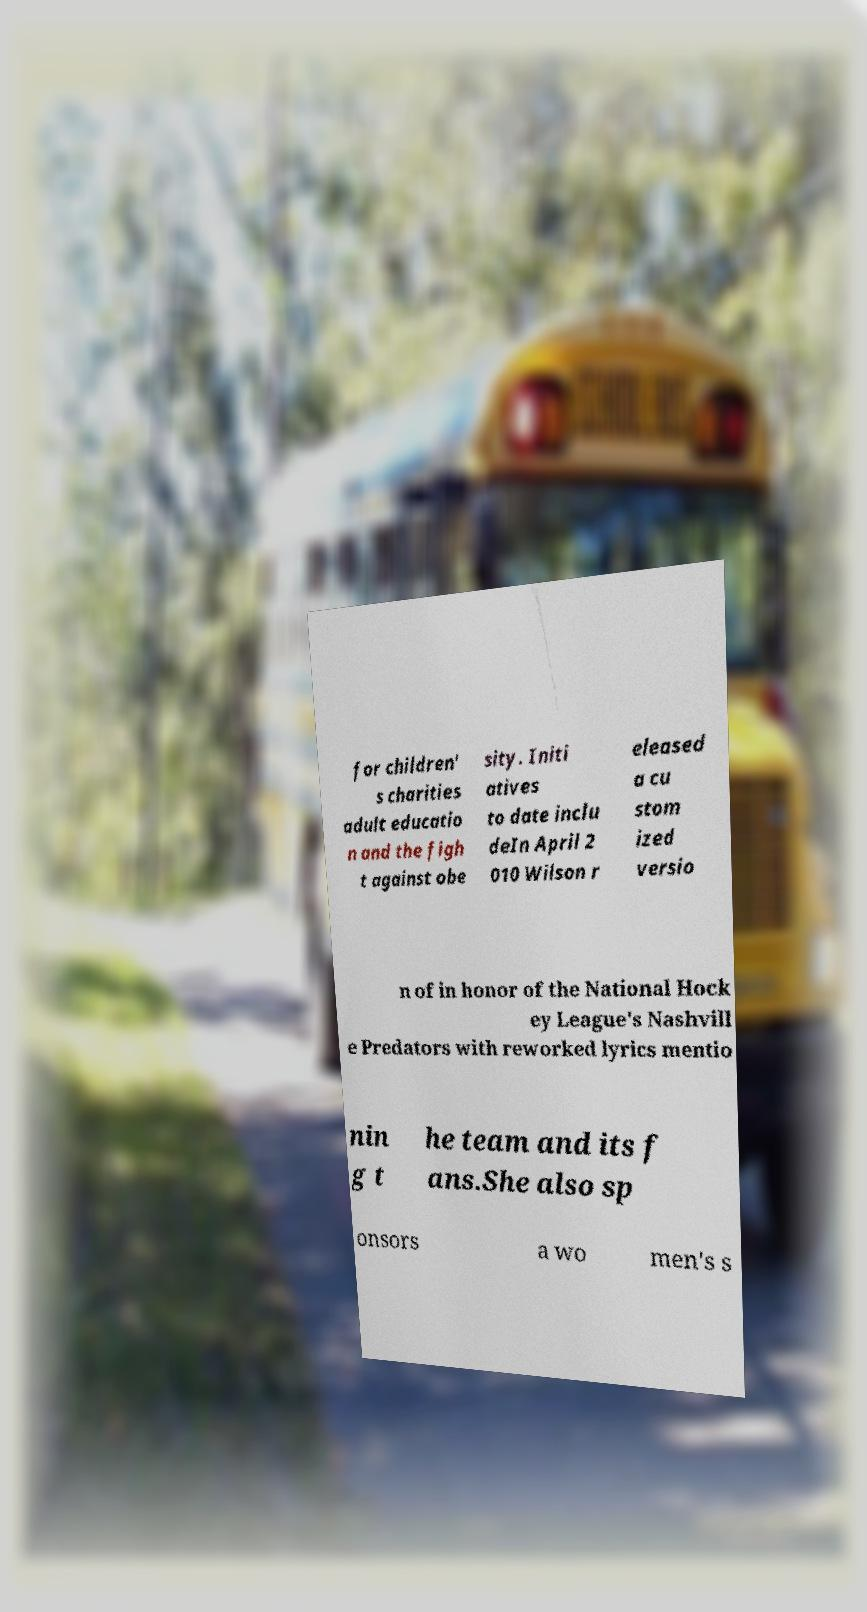I need the written content from this picture converted into text. Can you do that? for children' s charities adult educatio n and the figh t against obe sity. Initi atives to date inclu deIn April 2 010 Wilson r eleased a cu stom ized versio n of in honor of the National Hock ey League's Nashvill e Predators with reworked lyrics mentio nin g t he team and its f ans.She also sp onsors a wo men's s 